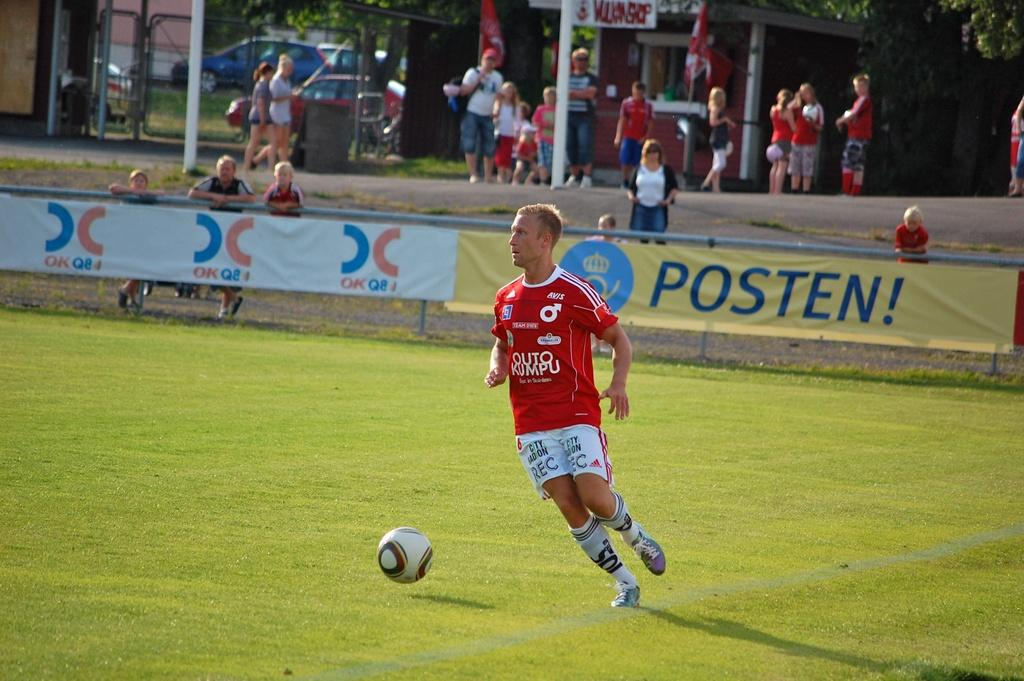<image>
Write a terse but informative summary of the picture. A soccer player is in front of a sign which has the word Posten! on it. 